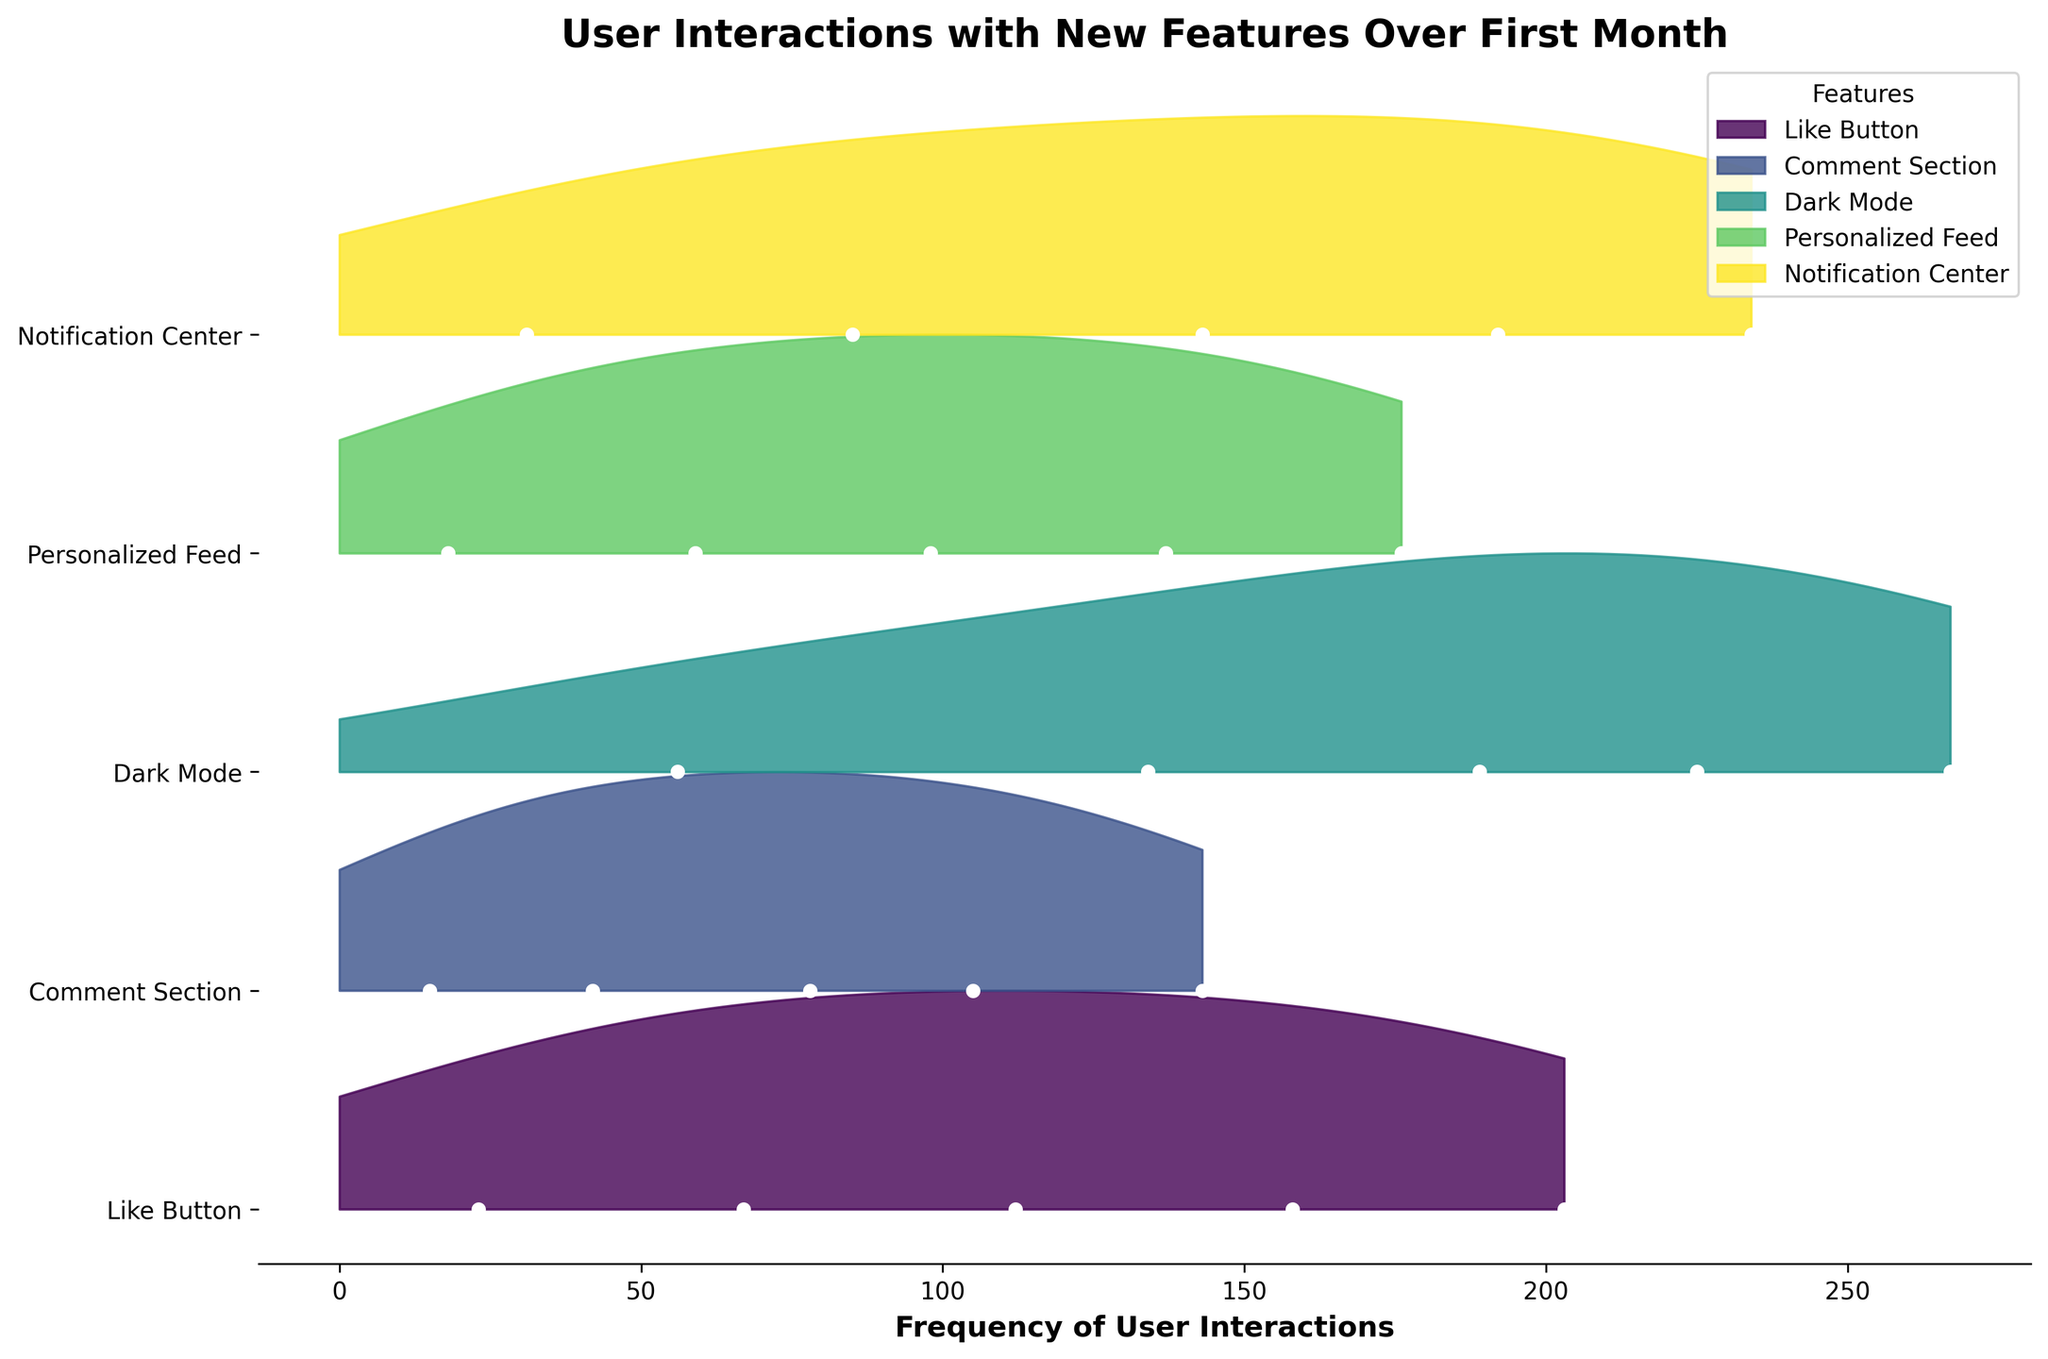what are the features shown in the plot? The figure legend shows the features being compared. The plot includes Like Button, Comment Section, Dark Mode, Personalized Feed, and Notification Center.
Answer: Like Button, Comment Section, Dark Mode, Personalized Feed, Notification Center Which feature has the highest frequency of interactions by the end of the first month? Look for the highest data point on the X-axis and identify which feature's line corresponds to it in the plot. Dark Mode has the highest frequency of interactions at day 30 with a frequency of 267.
Answer: Dark Mode Which feature had the lowest initial interaction frequency? Check the data points for day 1 and identify the feature with the lowest frequency value. The Comment Section had the lowest initial interaction frequency with 15 interactions on day 1.
Answer: Comment Section What trend can be observed for the Like Button interactions over the first month? Observe the plot line for the Like Button over time and describe the pattern. The Like Button interactions show a continuous increase throughout the month.
Answer: Continuous increase Compare the interaction frequency of the Notification Center and Comment Section on day 14. Look at the two corresponding data points and determine which is higher. On day 14, the Notification Center has a higher frequency of 143 compared to the Comment Section's 78.
Answer: Notification Center has a higher frequency By approximately how much did interactions with Dark Mode increase from day 7 to day 30? Subtract the frequency on day 7 from the frequency on day 30 for Dark Mode data points. The increase is 267 - 134 = 133.
Answer: 133 Which feature shows the most significant growth in user interactions over the month? Calculate the difference between the frequency at day 30 and day 1 for each feature and compare them. Dark Mode shows the most significant growth, with an increase of 267 - 56 = 211 interactions.
Answer: Dark Mode Is there any feature line that appears to run almost parallel to another between days 7 and 21? Observe the plot lines and identify if any two features show similar trends without significant diverging. Like Button and Personalized Feed have similar growth patterns between days 7 and 21, appearing almost parallel.
Answer: Like Button and Personalized Feed 